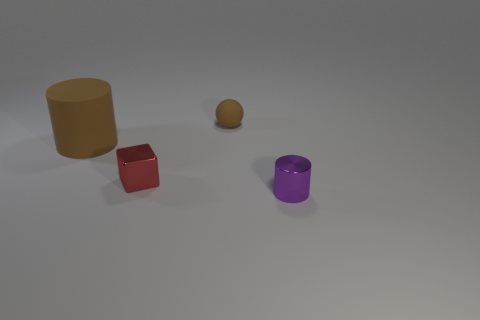Add 4 brown balls. How many objects exist? 8 Subtract 1 purple cylinders. How many objects are left? 3 Subtract all cubes. How many objects are left? 3 Subtract 1 spheres. How many spheres are left? 0 Subtract all gray balls. Subtract all red cubes. How many balls are left? 1 Subtract all gray spheres. How many purple blocks are left? 0 Subtract all matte things. Subtract all tiny spheres. How many objects are left? 1 Add 4 small purple metal cylinders. How many small purple metal cylinders are left? 5 Add 2 purple objects. How many purple objects exist? 3 